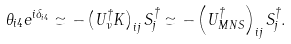Convert formula to latex. <formula><loc_0><loc_0><loc_500><loc_500>\theta _ { i 4 } e ^ { i \delta _ { i 4 } } \simeq - \left ( U _ { \nu } ^ { \dagger } K \right ) _ { i j } S _ { j } ^ { \dagger } \simeq - \left ( U _ { M N S } ^ { \dagger } \right ) _ { i j } S _ { j } ^ { \dagger } .</formula> 